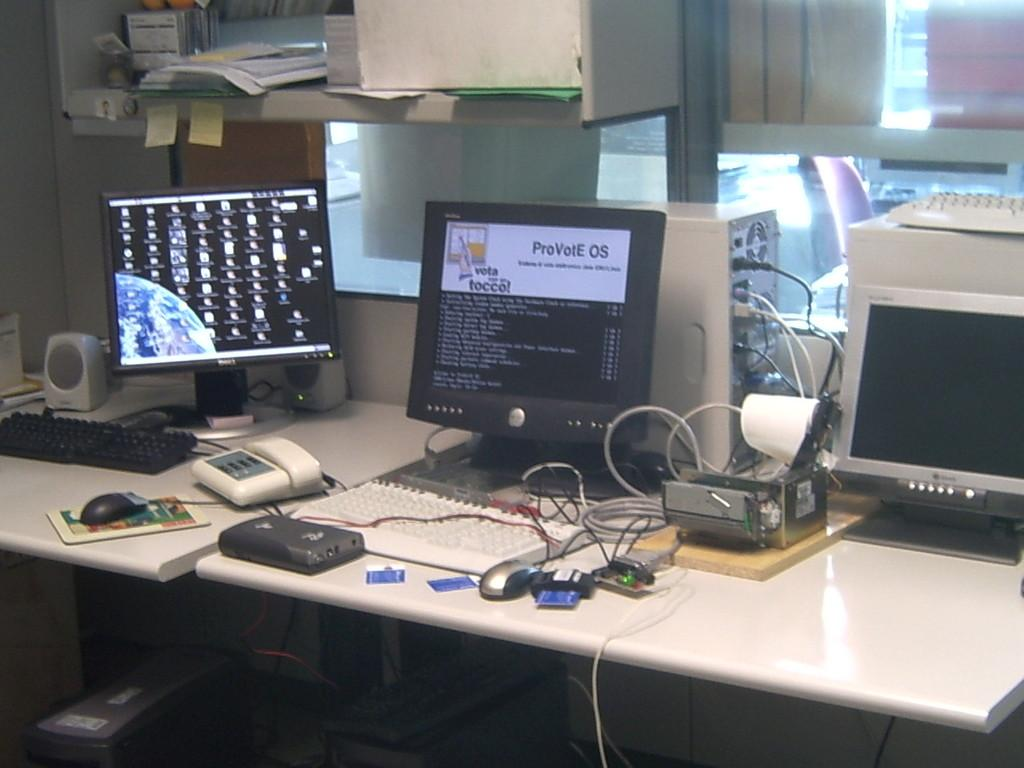What electronic devices are on the table in the image? There are monitors, keyboards, a telephone, a speaker, a device, and a CPU on the table in the image. What is used for input and output on the table? The keyboards and monitors are used for input and output on the table. What is the purpose of the telephone on the table? The telephone on the table is likely used for communication. What is the purpose of the speaker on the table? The speaker on the table is likely used for amplifying sound. What is the purpose of the cables on the table? The cables on the table are likely used for connecting and powering the electronic devices. What is the purpose of the book on the table? The book on the table may be used for reference or reading. What is above the table in the image? There is a rack above the table. What is stored in the rack above the table? The rack is filled with things, but their specific contents are not mentioned in the facts. How many trees can be seen in the image? There is no mention of trees in the image. Is there a camp visible in the image? There is no mention of a camp in the image. 